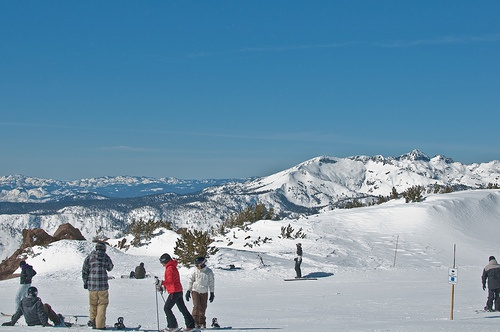Describe the objects in this image and their specific colors. I can see people in teal, gray, black, and darkgray tones, people in teal, black, lightgray, brown, and gray tones, people in teal, darkgray, black, gray, and lightgray tones, people in teal, black, gray, and blue tones, and people in teal, black, purple, and darkgray tones in this image. 